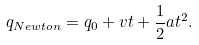<formula> <loc_0><loc_0><loc_500><loc_500>q _ { N e w t o n } = q _ { 0 } + v t + \frac { 1 } { 2 } a t ^ { 2 } .</formula> 